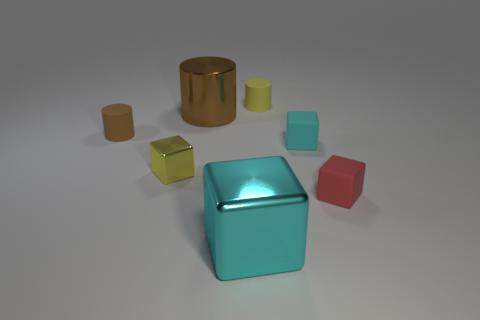There is a rubber object that is the same color as the tiny metal thing; what is its shape?
Ensure brevity in your answer.  Cylinder. Are there fewer tiny brown cylinders that are in front of the small brown matte cylinder than small green objects?
Your answer should be very brief. No. There is a object that is in front of the red matte block; is its size the same as the large brown cylinder?
Make the answer very short. Yes. How many other metal objects are the same shape as the small metal object?
Ensure brevity in your answer.  1. The cube that is the same material as the tiny red thing is what size?
Give a very brief answer. Small. Is the number of brown metal cylinders that are to the right of the big cyan block the same as the number of tiny blue rubber cylinders?
Offer a very short reply. Yes. There is a yellow object in front of the yellow rubber cylinder; does it have the same shape as the tiny yellow object that is to the right of the large cyan shiny object?
Make the answer very short. No. There is a small yellow thing that is the same shape as the red matte object; what is its material?
Give a very brief answer. Metal. There is a cube that is both behind the red rubber cube and to the right of the large brown object; what is its color?
Provide a short and direct response. Cyan. There is a small matte cube that is behind the small block left of the tiny cyan matte block; are there any brown metal objects that are behind it?
Provide a succinct answer. Yes. 